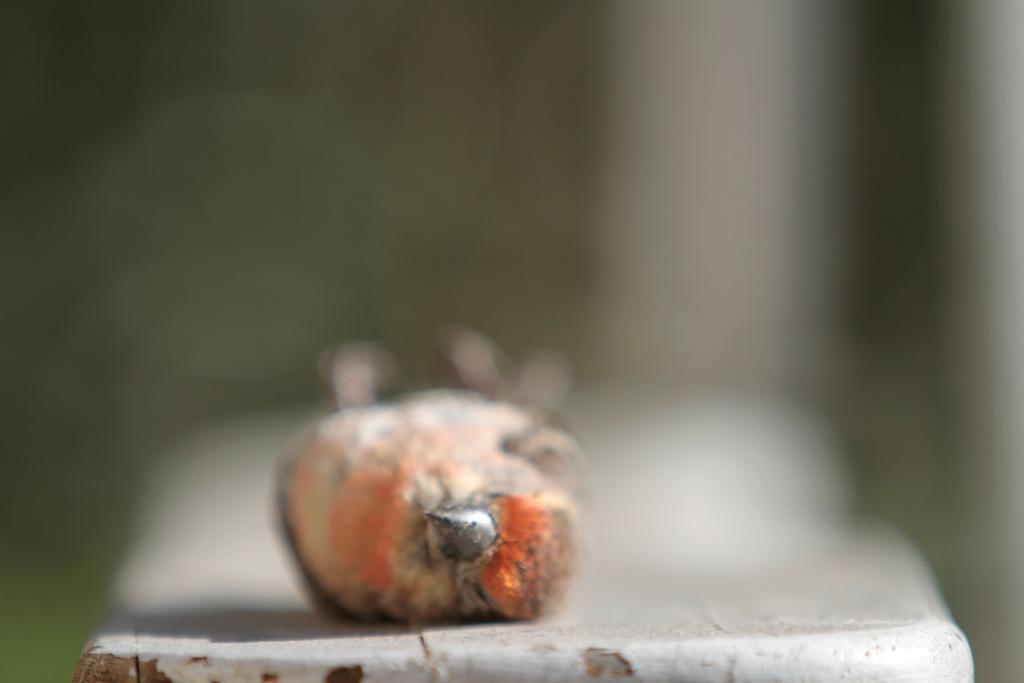Can you describe this image briefly? In this image we can see a bird. 